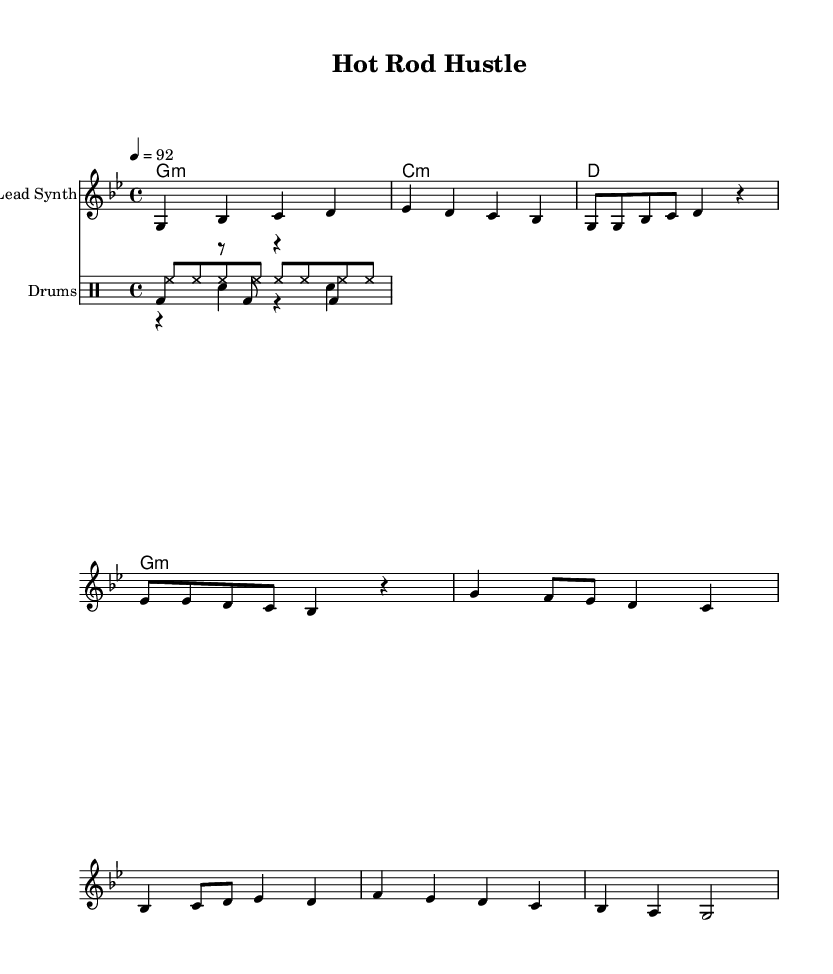What is the key signature of this music? The key signature is G minor, which has two flats (B flat and E flat). This can be confirmed by looking at the key signature indicated at the beginning of the staff, which defines the pitches used in the piece.
Answer: G minor What is the time signature of the piece? The time signature is 4/4, as noted at the start of the score. It shows that there are four beats in each measure and a quarter note receives one beat.
Answer: 4/4 What is the tempo marking of this music? The tempo marking is 92, which is noted in beats per minute. This indicates the speed at which the piece should be played, promoting a steady and moderate pace typical of hip hop.
Answer: 92 How many measures are in the chorus section? The chorus section contains 4 measures. By counting the grouped measures in the respective section of the score, we find that the chorus is comprised of four distinct groupings.
Answer: 4 What is the function of the kick drum in this score? The kick drum plays a foundational rhythmic role, providing a driving pulse throughout the piece. Observing the drummode notation reveals it complements the other percussion instruments, emphasizing the beat.
Answer: Foundation What are the three main parts of the composition? The three main parts of this composition are the Intro, Verse, and Chorus, which show a structure often used in music, allowing for a progression of themes and musical ideas. Each segment serves a distinct purpose in the song's development.
Answer: Intro, Verse, Chorus How does the harmony relate to the melody in the piece? The harmony supports the melody by providing chords that underlie the melodic lines. The chord progression is in G minor, which aligns with the notes of the melody, ensuring harmonic cohesion and reinforcing the musical narrative.
Answer: Support 